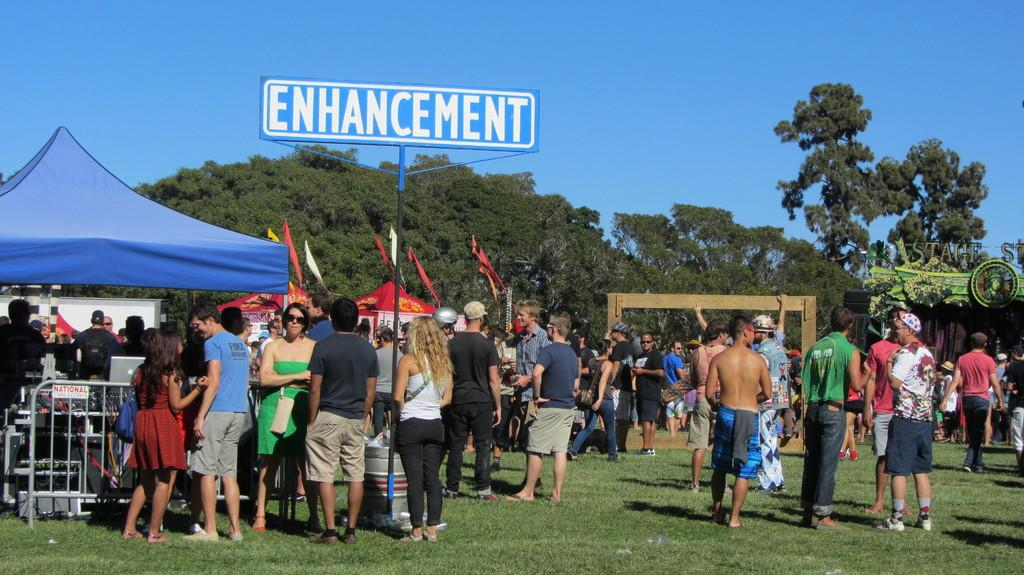What is happening with the group of people in the image? The group of people is on the ground in the image. What object can be seen with the group of people? There is a name board in the image. What type of temporary shelters are present in the image? There are tents in the image. What other objects can be seen in the image? There are flags in the image. What natural elements are visible in the image? There are trees in the image. What type of mine can be seen in the image? There is no mine present in the image. What does the lunchroom smell like in the image? There is no lunchroom present in the image, so it cannot be determined what it might smell like. 